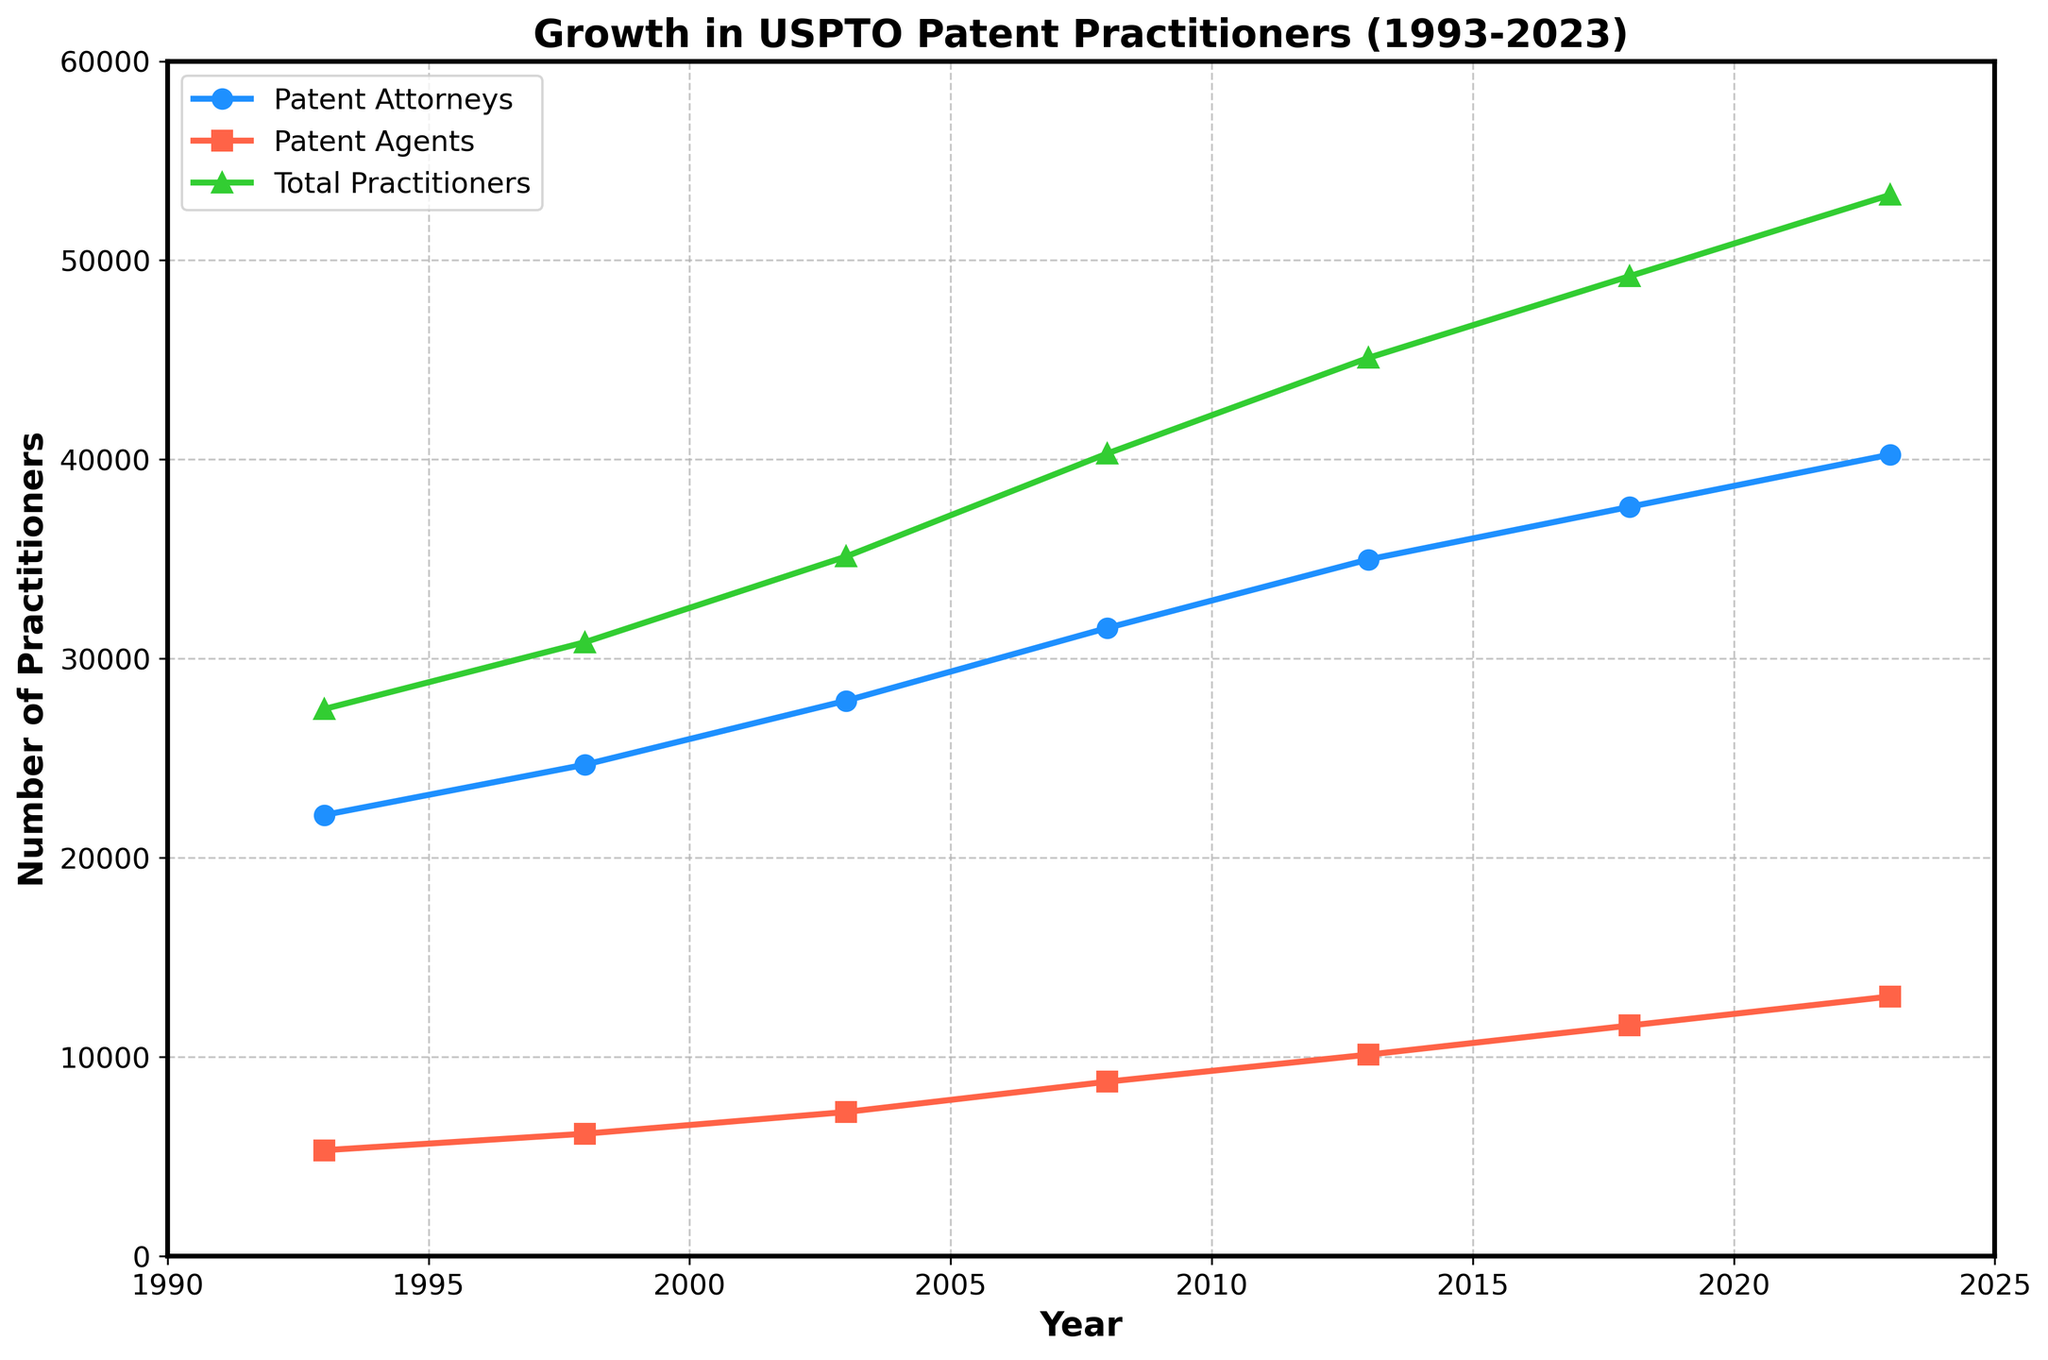What's the overall trend in the number of registered patent attorneys from 1993 to 2023? Observing the blue line representing the registered patent attorneys, we see a consistent upward trend from 1993 (22150 attorneys) to 2023 (40250 attorneys).
Answer: Upward trend How many registered patent practitioners were there in total in 2003? Looking at the green line or the data point marked in 2003, we can see that the total number of registered patent practitioners was 35130.
Answer: 35130 By how much did the number of registered patent agents increase between 1993 and 2023? Reviewing the red line, the number of registered patent agents in 1993 was 5320, and in 2023 it was 13040. The increase is calculated as 13040 - 5320 = 7720.
Answer: 7720 Which year had the most significant increase in the number of total USPTO practitioners? Evaluating the green line at each data point, the most significant increase appears when comparing the steepest segment. The total practitioners increased from 2008 (40300) to 2013 (45100), an increment of 4800. This segment shows the most noticeable growth.
Answer: 2008-2013 Between which two consecutive years was the growth rate of registered patent attorneys the lowest? Examining each segment of the blue line, the growth rate of registered patent attorneys appears to be the lowest between 2018 (37620) and 2023 (40250). The increase was 40250 - 37620 = 2630, which is the smallest increment between any two consecutive data points.
Answer: 2018-2023 How does the growth of registered patent agents compare to registered patent attorneys from 1993 to 2023? From 1993 to 2023, registered patent agents increased from 5320 to 13040, a growth of 7720. Registered patent attorneys increased from 22150 to 40250, a growth of 18100. Therefore, the number of registered patent attorneys grew more in absolute terms than registered patent agents.
Answer: Attorneys grew more What is the approximate average number of total USPTO practitioners per year shown in the data? Adding the total practitioners for all years: 27470 + 30830 + 35130 + 40300 + 45100 + 49200 + 53290 = 281320. There are 7 data points, so the average is 281320 / 7 ≈ 40189.
Answer: 40189 In which year did the number of registered patent attorneys first exceed 30000? Looking at the blue line, the number of registered patent attorneys first exceeds 30000 in 2008, where the number was 31540.
Answer: 2008 What percentage of the total practitioners were registered patent agents in 2013? In 2013, there were 45100 total practitioners and 10120 registered patent agents. The percentage is (10120 / 45100) * 100% ≈ 22.42%.
Answer: 22.42% Compare the growth rates of patent agents and attorneys between 2003 and 2008. In 2003, there were 27890 attorneys and 7240 agents. In 2008, there were 31540 attorneys and 8760 agents. Growth for attorneys: (31540 - 27890) / 27890 ≈ 0.131 (13.1%), and for agents: (8760 - 7240) / 7240 ≈ 0.21 (21%). Thus, patent agents had a higher growth rate than attorneys between 2003 and 2008.
Answer: Agents had higher growth rate 